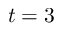Convert formula to latex. <formula><loc_0><loc_0><loc_500><loc_500>t = 3</formula> 